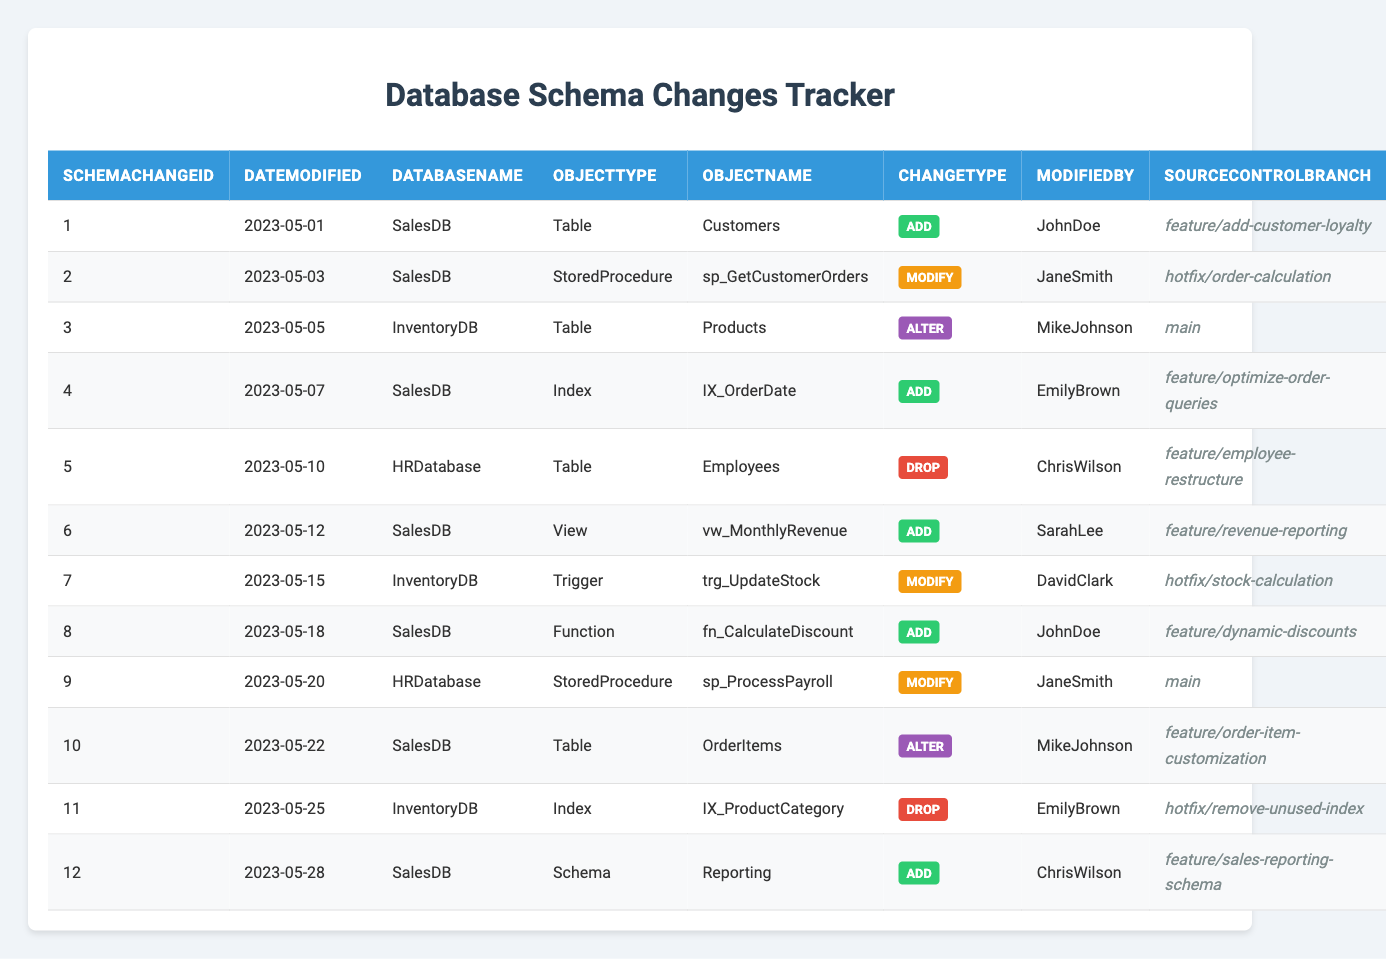What types of schema changes were made to SalesDB? In the table, the ObjectType values corresponding to SalesDB are "Table," "StoredProcedure," "Index," "View," "Function," and "Schema." This shows various modifications ranging from adding new tables and views to altering existing ones.
Answer: Table, StoredProcedure, Index, View, Function, Schema Who modified the Employees table in HRDatabase? The table lists a change for the Employees table under the ModifiedBy column, which shows "ChrisWilson" as the user responsible for this drop change.
Answer: ChrisWilson How many schema changes were made in May 2023? By counting the entries in the DateModified column for May 2023, we see there are 12 schema changes recorded during this period.
Answer: 12 What was the last change made to the InventoryDB? The last entry in the table records a change for InventoryDB on "2023-05-28," where a modification was made related to an Index. The entry indicates that there were no subsequent changes for InventoryDB after this date.
Answer: Modification to Index Was there any schema change made to the HRDatabase as an addition? Looking at the ChangeType for HRDatabase, the table shows "Drop" and "Modify" changes, but no entries are listed under "Add," indicating no additions were made.
Answer: No Which user made the most changes in the SalesDB? By reviewing the ModifiedBy column, "JohnDoe" appears twice and did an "Add" for both changes in SalesDB, which makes him the user with the most changes.
Answer: JohnDoe How many different ChangeTypes were recorded for the InventoryDB? The table shows "Alter," "Modify," and "Drop" as the ChangeTypes for InventoryDB. Counting these unique types results in three different ChangeTypes.
Answer: 3 What is the earliest schema change recorded in the database? The earliest date in the DateModified column is "2023-05-01," and the corresponding entry is for the "Customers" table in SalesDB marked as "Add."
Answer: 2023-05-01 How many changes were made under the branch 'feature/add-customer-loyalty'? There is one entry in the table with the SourceControlBranch 'feature/add-customer-loyalty,' indicating a single change made.
Answer: 1 Which database had the highest number of modifications? By counting changes in SalesDB (7), HRDatabase (2), and InventoryDB (3), SalesDB has the highest count, having seven modifications recorded in the table.
Answer: SalesDB What was the first modification made to the Customers table? The Customers table was first added on "2023-05-01" as indicated in the data, so there haven't been any modifications made to it yet, only the addition.
Answer: Add 